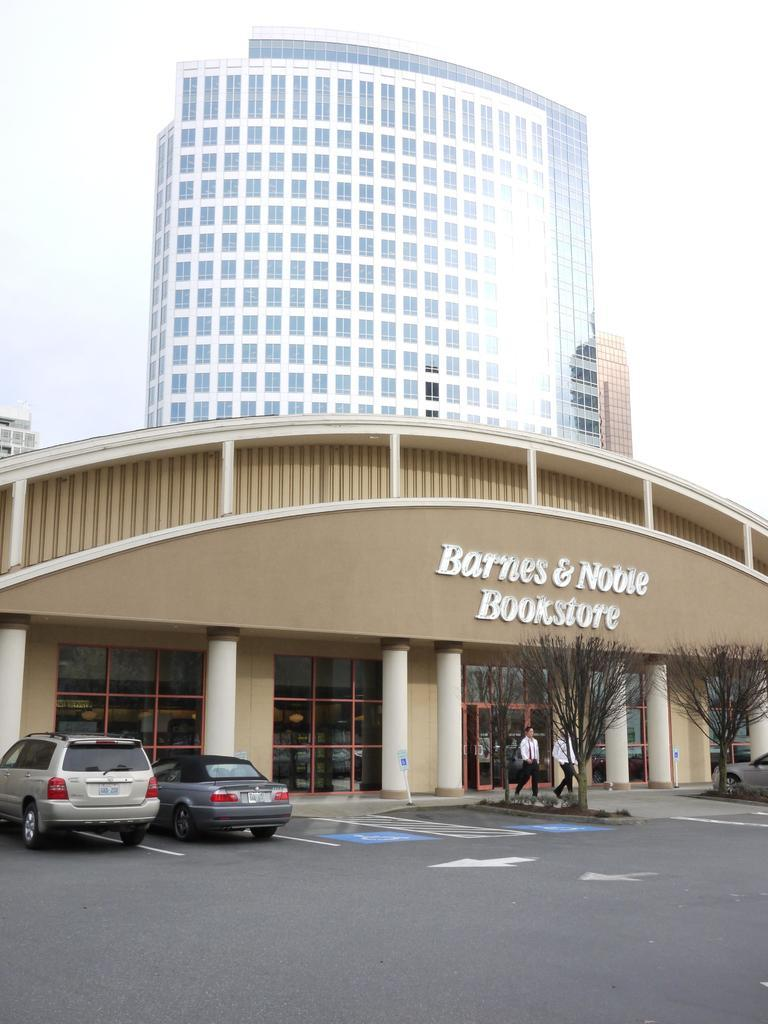What can be seen on the road in the image? There are vehicles on the road in the image. What type of natural elements are visible in the image? There are trees visible in the image. What architectural features can be seen in the image? There are pillars and buildings with windows in the image. What activity are two people engaged in within the image? Two people are walking on the ground in the image. What is visible in the background of the image? The sky is visible in the background of the image. What type of straw is being used by the people walking on the ground in the image? There is no straw present in the image; the two people are walking without any visible objects in their hands. What fictional characters can be seen interacting with the buildings in the image? There are no fictional characters present in the image; the buildings are depicted realistically. 